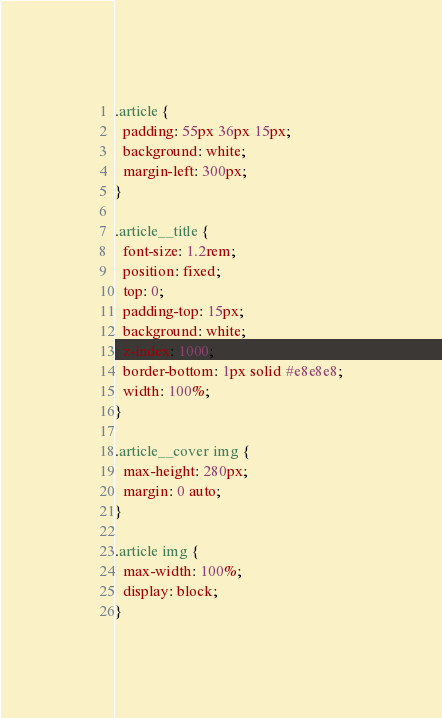Convert code to text. <code><loc_0><loc_0><loc_500><loc_500><_CSS_>.article {
  padding: 55px 36px 15px;
  background: white;
  margin-left: 300px;
}

.article__title {
  font-size: 1.2rem;
  position: fixed;
  top: 0;
  padding-top: 15px;
  background: white;
  z-index: 1000;
  border-bottom: 1px solid #e8e8e8;
  width: 100%;
}

.article__cover img {
  max-height: 280px;
  margin: 0 auto;
}

.article img {
  max-width: 100%;
  display: block;
}
</code> 